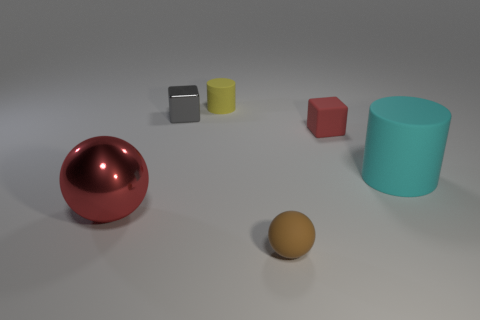Do the tiny matte cube and the large shiny sphere have the same color?
Ensure brevity in your answer.  Yes. What size is the cyan rubber object that is the same shape as the small yellow thing?
Make the answer very short. Large. There is a tiny object that is the same color as the metallic ball; what material is it?
Provide a succinct answer. Rubber. Does the brown matte sphere have the same size as the rubber block?
Your answer should be very brief. Yes. What size is the rubber object to the right of the block that is on the right side of the small cylinder?
Provide a succinct answer. Large. Do the metallic ball and the block that is on the right side of the tiny matte ball have the same color?
Provide a short and direct response. Yes. Are there any red metallic objects of the same size as the cyan matte thing?
Make the answer very short. Yes. What is the size of the red thing that is left of the tiny matte ball?
Provide a succinct answer. Large. Is there a tiny matte thing that is on the right side of the rubber cylinder that is on the left side of the tiny ball?
Offer a terse response. Yes. What number of other things are the same shape as the small gray thing?
Your answer should be very brief. 1. 